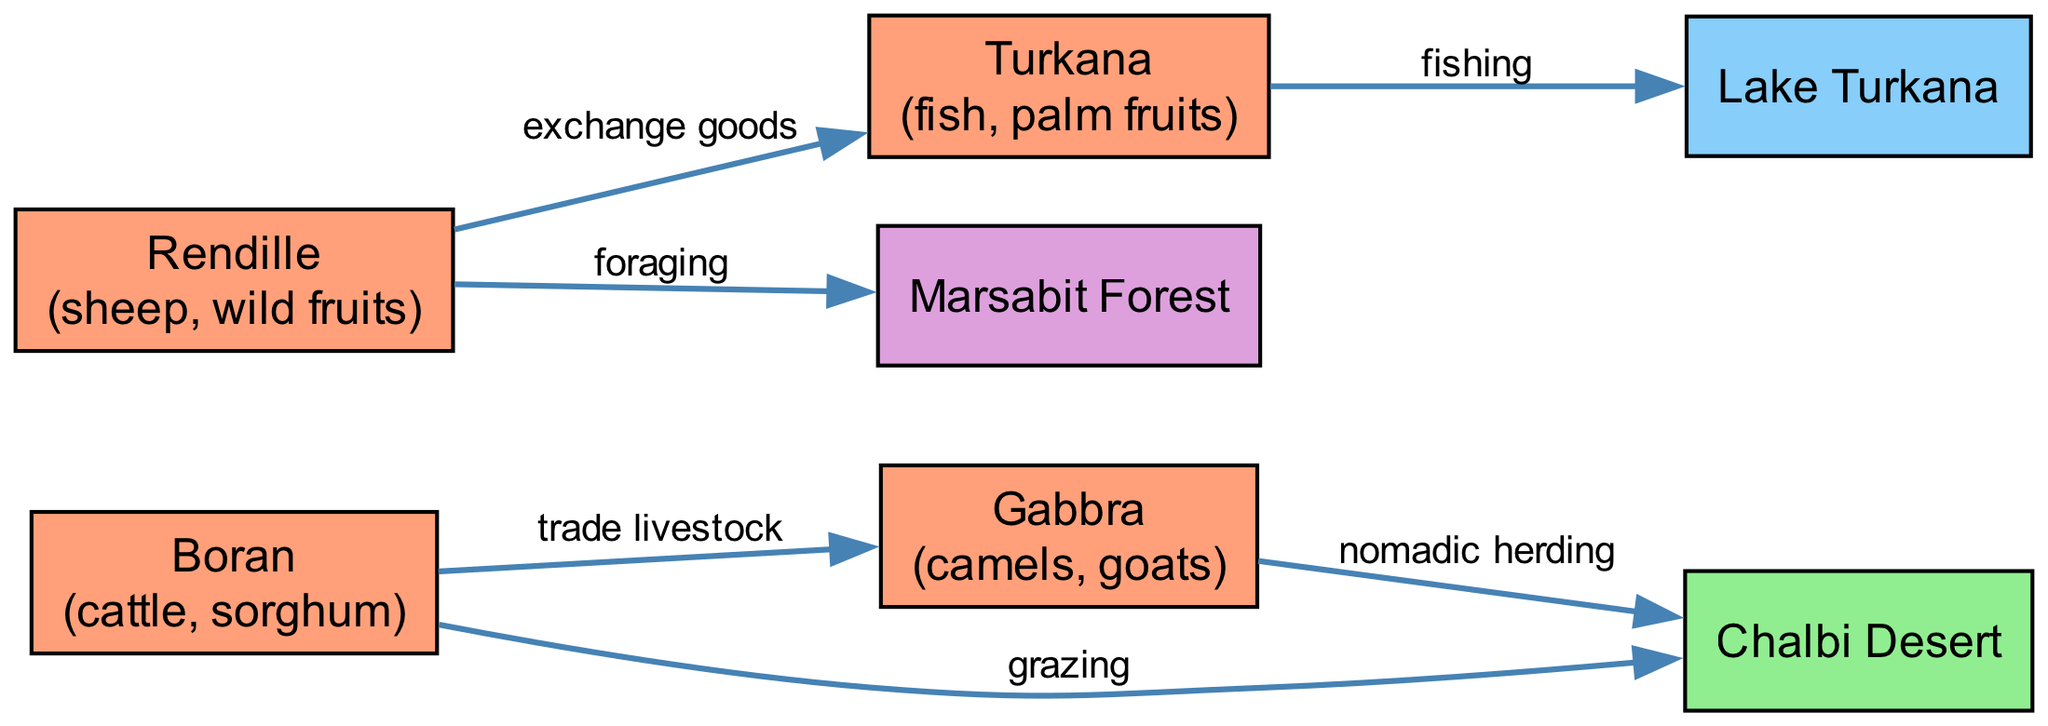What resources does the Boran clan utilize? The Boran clan’s node in the diagram lists the resources it utilizes, which are specifically cattle and sorghum.
Answer: cattle, sorghum How many clans are depicted in the diagram? By counting the nodes labeled as clans, we find four distinct clans: Boran, Gabbra, Rendille, and Turkana.
Answer: 4 What is the relationship between the Gabbra and the Chalbi Desert? The edge connecting the Gabbra clan to Chalbi Desert is labeled "nomadic herding," indicating this direct utilization of the grazing land by the clan.
Answer: nomadic herding Which clan forages in the Marsabit Forest? The Rendille clan’s node specifies their activity related to Marsabit Forest, which is foraging.
Answer: Rendille How many edges are in the diagram? By counting each connection (edge) between nodes, we identify a total of six edges present in the diagram.
Answer: 6 What resources do the Turkana clan obtain from Lake Turkana? The Turkana clan's relationship to Lake Turkana, indicated by the edge labeled "fishing," specifies the resource they obtain, which is fish.
Answer: fish Which clan trades livestock with the Boran clan? The diagram connects the Boran clan to the Gabbra clan with an edge labeled "trade livestock," confirming their trading relationship.
Answer: Gabbra What kind of land is the Chalbi Desert classified as? The Chalbi Desert node is categorized specifically as grazing land within the diagram, which describes its primary function.
Answer: grazing land What type of resource do the Rendille clan utilize? The Rendille clan's node indicates their resources to be sheep and wild fruits, which are clearly identified in their listing.
Answer: sheep, wild fruits What is the connection between the Rendille and Turkana clans? The diagram shows an edge connecting Rendille to Turkana labeled "exchange goods," representing their interaction in trade.
Answer: exchange goods 